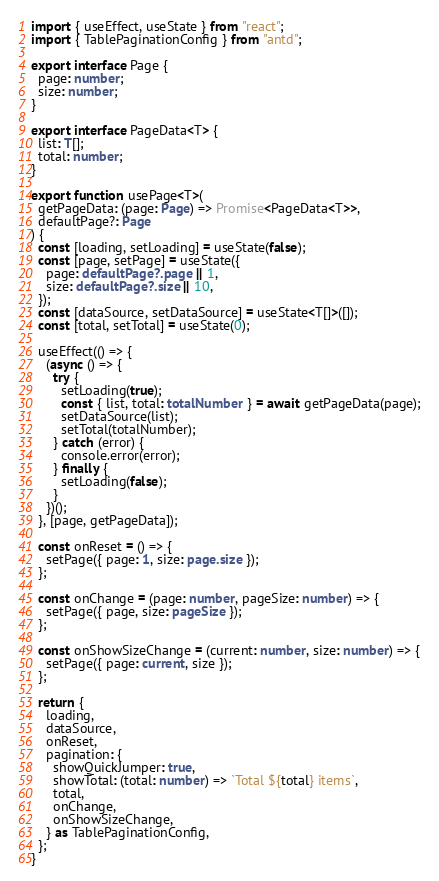<code> <loc_0><loc_0><loc_500><loc_500><_TypeScript_>import { useEffect, useState } from "react";
import { TablePaginationConfig } from "antd";

export interface Page {
  page: number;
  size: number;
}

export interface PageData<T> {
  list: T[];
  total: number;
}

export function usePage<T>(
  getPageData: (page: Page) => Promise<PageData<T>>,
  defaultPage?: Page
) {
  const [loading, setLoading] = useState(false);
  const [page, setPage] = useState({
    page: defaultPage?.page || 1,
    size: defaultPage?.size || 10,
  });
  const [dataSource, setDataSource] = useState<T[]>([]);
  const [total, setTotal] = useState(0);

  useEffect(() => {
    (async () => {
      try {
        setLoading(true);
        const { list, total: totalNumber } = await getPageData(page);
        setDataSource(list);
        setTotal(totalNumber);
      } catch (error) {
        console.error(error);
      } finally {
        setLoading(false);
      }
    })();
  }, [page, getPageData]);

  const onReset = () => {
    setPage({ page: 1, size: page.size });
  };

  const onChange = (page: number, pageSize: number) => {
    setPage({ page, size: pageSize });
  };

  const onShowSizeChange = (current: number, size: number) => {
    setPage({ page: current, size });
  };

  return {
    loading,
    dataSource,
    onReset,
    pagination: {
      showQuickJumper: true,
      showTotal: (total: number) => `Total ${total} items`,
      total,
      onChange,
      onShowSizeChange,
    } as TablePaginationConfig,
  };
}
</code> 